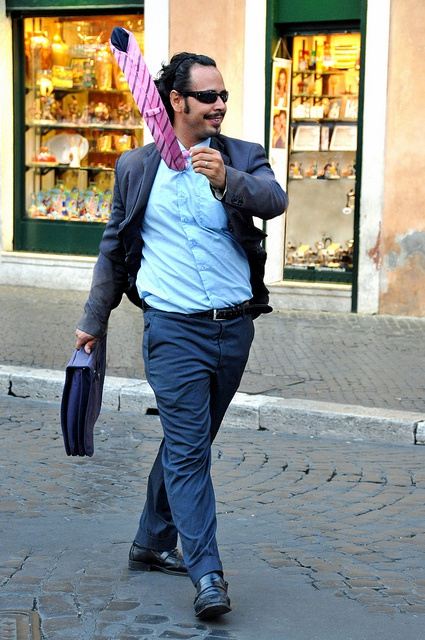Describe the objects in this image and their specific colors. I can see people in darkgray, black, navy, lightblue, and darkblue tones, handbag in darkgray, black, and navy tones, tie in darkgray, violet, pink, and purple tones, vase in darkgray, orange, gold, and yellow tones, and vase in darkgray, red, and orange tones in this image. 